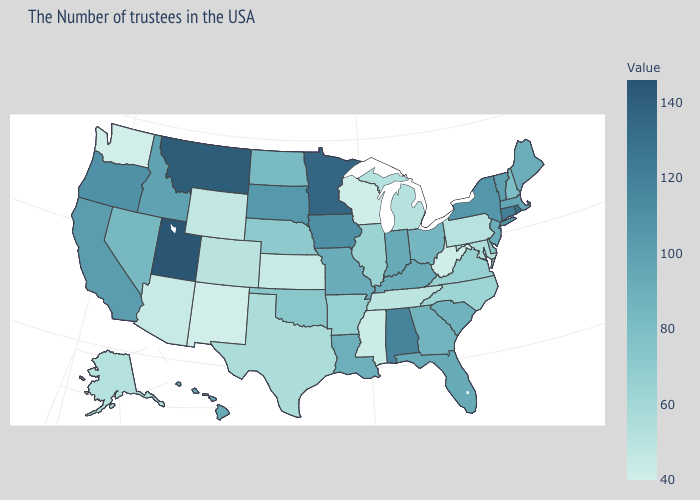Among the states that border Nevada , does California have the lowest value?
Write a very short answer. No. Does Michigan have a higher value than New Hampshire?
Answer briefly. No. Which states have the lowest value in the West?
Give a very brief answer. New Mexico, Washington. Among the states that border North Carolina , which have the lowest value?
Write a very short answer. Tennessee. Does Nebraska have a higher value than Washington?
Give a very brief answer. Yes. 